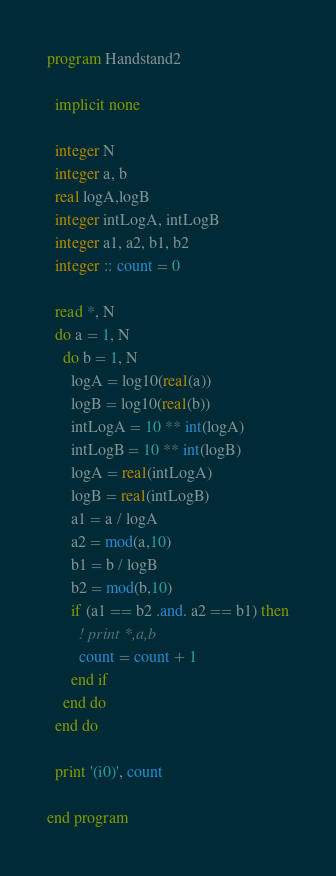<code> <loc_0><loc_0><loc_500><loc_500><_FORTRAN_>program Handstand2

  implicit none

  integer N
  integer a, b
  real logA,logB
  integer intLogA, intLogB
  integer a1, a2, b1, b2
  integer :: count = 0

  read *, N
  do a = 1, N
    do b = 1, N
      logA = log10(real(a))
      logB = log10(real(b))
      intLogA = 10 ** int(logA)
      intLogB = 10 ** int(logB)
      logA = real(intLogA)
      logB = real(intLogB)
      a1 = a / logA
      a2 = mod(a,10)
      b1 = b / logB
      b2 = mod(b,10)
      if (a1 == b2 .and. a2 == b1) then
        ! print *,a,b
        count = count + 1
      end if
    end do
  end do

  print '(i0)', count

end program
</code> 